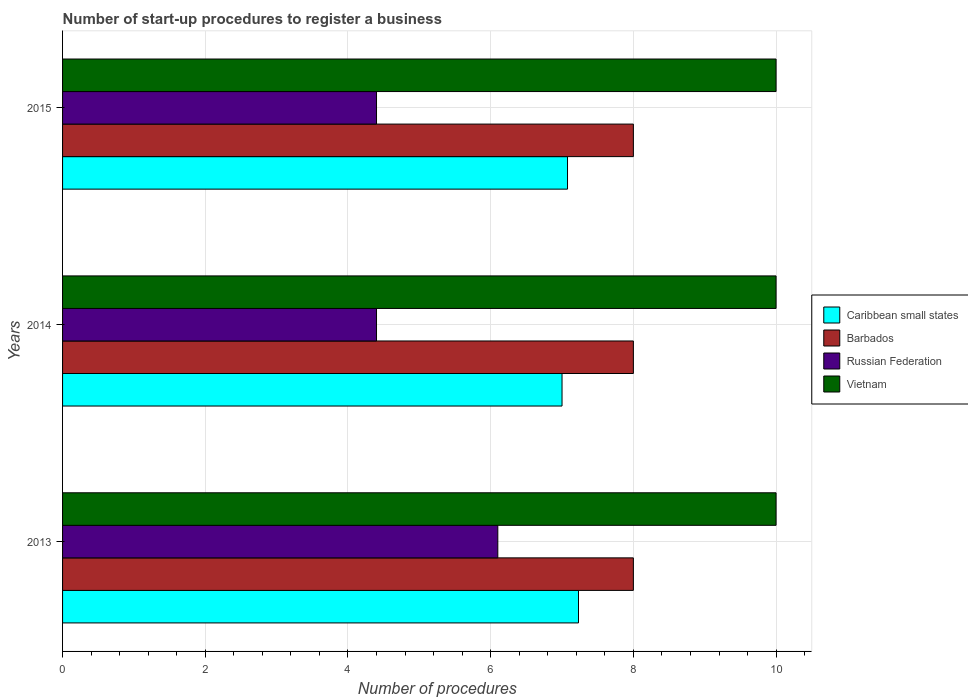How many different coloured bars are there?
Your answer should be compact. 4. Are the number of bars per tick equal to the number of legend labels?
Provide a short and direct response. Yes. Are the number of bars on each tick of the Y-axis equal?
Offer a very short reply. Yes. How many bars are there on the 2nd tick from the top?
Your response must be concise. 4. How many bars are there on the 3rd tick from the bottom?
Offer a very short reply. 4. Across all years, what is the maximum number of procedures required to register a business in Vietnam?
Provide a short and direct response. 10. Across all years, what is the minimum number of procedures required to register a business in Vietnam?
Make the answer very short. 10. In which year was the number of procedures required to register a business in Russian Federation minimum?
Give a very brief answer. 2014. What is the difference between the number of procedures required to register a business in Caribbean small states in 2013 and that in 2014?
Make the answer very short. 0.23. What is the difference between the number of procedures required to register a business in Russian Federation in 2014 and the number of procedures required to register a business in Vietnam in 2015?
Give a very brief answer. -5.6. What is the average number of procedures required to register a business in Caribbean small states per year?
Ensure brevity in your answer.  7.1. In the year 2014, what is the difference between the number of procedures required to register a business in Caribbean small states and number of procedures required to register a business in Russian Federation?
Give a very brief answer. 2.6. Is the difference between the number of procedures required to register a business in Caribbean small states in 2013 and 2014 greater than the difference between the number of procedures required to register a business in Russian Federation in 2013 and 2014?
Provide a short and direct response. No. What is the difference between the highest and the second highest number of procedures required to register a business in Vietnam?
Give a very brief answer. 0. In how many years, is the number of procedures required to register a business in Caribbean small states greater than the average number of procedures required to register a business in Caribbean small states taken over all years?
Your answer should be compact. 1. Is the sum of the number of procedures required to register a business in Caribbean small states in 2013 and 2015 greater than the maximum number of procedures required to register a business in Vietnam across all years?
Make the answer very short. Yes. What does the 2nd bar from the top in 2015 represents?
Your answer should be very brief. Russian Federation. What does the 1st bar from the bottom in 2013 represents?
Give a very brief answer. Caribbean small states. Are all the bars in the graph horizontal?
Offer a terse response. Yes. How many years are there in the graph?
Your answer should be very brief. 3. Where does the legend appear in the graph?
Give a very brief answer. Center right. What is the title of the graph?
Your response must be concise. Number of start-up procedures to register a business. What is the label or title of the X-axis?
Your answer should be compact. Number of procedures. What is the Number of procedures in Caribbean small states in 2013?
Provide a short and direct response. 7.23. What is the Number of procedures of Caribbean small states in 2014?
Offer a terse response. 7. What is the Number of procedures in Barbados in 2014?
Ensure brevity in your answer.  8. What is the Number of procedures in Vietnam in 2014?
Make the answer very short. 10. What is the Number of procedures of Caribbean small states in 2015?
Your answer should be compact. 7.08. What is the Number of procedures of Russian Federation in 2015?
Keep it short and to the point. 4.4. What is the Number of procedures in Vietnam in 2015?
Provide a succinct answer. 10. Across all years, what is the maximum Number of procedures in Caribbean small states?
Offer a terse response. 7.23. Across all years, what is the maximum Number of procedures of Vietnam?
Keep it short and to the point. 10. Across all years, what is the minimum Number of procedures in Caribbean small states?
Keep it short and to the point. 7. Across all years, what is the minimum Number of procedures of Russian Federation?
Your response must be concise. 4.4. What is the total Number of procedures of Caribbean small states in the graph?
Keep it short and to the point. 21.31. What is the total Number of procedures of Barbados in the graph?
Your response must be concise. 24. What is the total Number of procedures in Russian Federation in the graph?
Provide a short and direct response. 14.9. What is the total Number of procedures in Vietnam in the graph?
Provide a succinct answer. 30. What is the difference between the Number of procedures of Caribbean small states in 2013 and that in 2014?
Your response must be concise. 0.23. What is the difference between the Number of procedures in Barbados in 2013 and that in 2014?
Your response must be concise. 0. What is the difference between the Number of procedures in Vietnam in 2013 and that in 2014?
Make the answer very short. 0. What is the difference between the Number of procedures of Caribbean small states in 2013 and that in 2015?
Provide a succinct answer. 0.15. What is the difference between the Number of procedures in Barbados in 2013 and that in 2015?
Offer a very short reply. 0. What is the difference between the Number of procedures in Russian Federation in 2013 and that in 2015?
Offer a terse response. 1.7. What is the difference between the Number of procedures of Caribbean small states in 2014 and that in 2015?
Make the answer very short. -0.08. What is the difference between the Number of procedures of Barbados in 2014 and that in 2015?
Your answer should be compact. 0. What is the difference between the Number of procedures of Russian Federation in 2014 and that in 2015?
Provide a succinct answer. 0. What is the difference between the Number of procedures in Caribbean small states in 2013 and the Number of procedures in Barbados in 2014?
Provide a succinct answer. -0.77. What is the difference between the Number of procedures in Caribbean small states in 2013 and the Number of procedures in Russian Federation in 2014?
Ensure brevity in your answer.  2.83. What is the difference between the Number of procedures of Caribbean small states in 2013 and the Number of procedures of Vietnam in 2014?
Your answer should be compact. -2.77. What is the difference between the Number of procedures of Barbados in 2013 and the Number of procedures of Russian Federation in 2014?
Your answer should be very brief. 3.6. What is the difference between the Number of procedures in Caribbean small states in 2013 and the Number of procedures in Barbados in 2015?
Provide a succinct answer. -0.77. What is the difference between the Number of procedures in Caribbean small states in 2013 and the Number of procedures in Russian Federation in 2015?
Offer a terse response. 2.83. What is the difference between the Number of procedures of Caribbean small states in 2013 and the Number of procedures of Vietnam in 2015?
Your answer should be compact. -2.77. What is the difference between the Number of procedures of Barbados in 2013 and the Number of procedures of Russian Federation in 2015?
Offer a terse response. 3.6. What is the difference between the Number of procedures of Caribbean small states in 2014 and the Number of procedures of Barbados in 2015?
Ensure brevity in your answer.  -1. What is the difference between the Number of procedures in Caribbean small states in 2014 and the Number of procedures in Russian Federation in 2015?
Your response must be concise. 2.6. What is the average Number of procedures in Caribbean small states per year?
Your response must be concise. 7.1. What is the average Number of procedures of Barbados per year?
Provide a short and direct response. 8. What is the average Number of procedures of Russian Federation per year?
Your answer should be compact. 4.97. In the year 2013, what is the difference between the Number of procedures in Caribbean small states and Number of procedures in Barbados?
Provide a succinct answer. -0.77. In the year 2013, what is the difference between the Number of procedures of Caribbean small states and Number of procedures of Russian Federation?
Give a very brief answer. 1.13. In the year 2013, what is the difference between the Number of procedures in Caribbean small states and Number of procedures in Vietnam?
Your answer should be very brief. -2.77. In the year 2014, what is the difference between the Number of procedures in Caribbean small states and Number of procedures in Russian Federation?
Your answer should be very brief. 2.6. In the year 2014, what is the difference between the Number of procedures of Russian Federation and Number of procedures of Vietnam?
Make the answer very short. -5.6. In the year 2015, what is the difference between the Number of procedures in Caribbean small states and Number of procedures in Barbados?
Keep it short and to the point. -0.92. In the year 2015, what is the difference between the Number of procedures of Caribbean small states and Number of procedures of Russian Federation?
Ensure brevity in your answer.  2.68. In the year 2015, what is the difference between the Number of procedures in Caribbean small states and Number of procedures in Vietnam?
Give a very brief answer. -2.92. In the year 2015, what is the difference between the Number of procedures of Barbados and Number of procedures of Vietnam?
Make the answer very short. -2. What is the ratio of the Number of procedures in Caribbean small states in 2013 to that in 2014?
Provide a short and direct response. 1.03. What is the ratio of the Number of procedures of Barbados in 2013 to that in 2014?
Provide a short and direct response. 1. What is the ratio of the Number of procedures of Russian Federation in 2013 to that in 2014?
Provide a succinct answer. 1.39. What is the ratio of the Number of procedures of Vietnam in 2013 to that in 2014?
Offer a very short reply. 1. What is the ratio of the Number of procedures in Caribbean small states in 2013 to that in 2015?
Your answer should be very brief. 1.02. What is the ratio of the Number of procedures of Russian Federation in 2013 to that in 2015?
Your response must be concise. 1.39. What is the ratio of the Number of procedures of Vietnam in 2013 to that in 2015?
Make the answer very short. 1. What is the ratio of the Number of procedures in Caribbean small states in 2014 to that in 2015?
Offer a very short reply. 0.99. What is the ratio of the Number of procedures in Barbados in 2014 to that in 2015?
Keep it short and to the point. 1. What is the ratio of the Number of procedures in Russian Federation in 2014 to that in 2015?
Keep it short and to the point. 1. What is the difference between the highest and the second highest Number of procedures of Caribbean small states?
Offer a terse response. 0.15. What is the difference between the highest and the second highest Number of procedures of Vietnam?
Your response must be concise. 0. What is the difference between the highest and the lowest Number of procedures in Caribbean small states?
Provide a short and direct response. 0.23. What is the difference between the highest and the lowest Number of procedures in Russian Federation?
Offer a terse response. 1.7. 